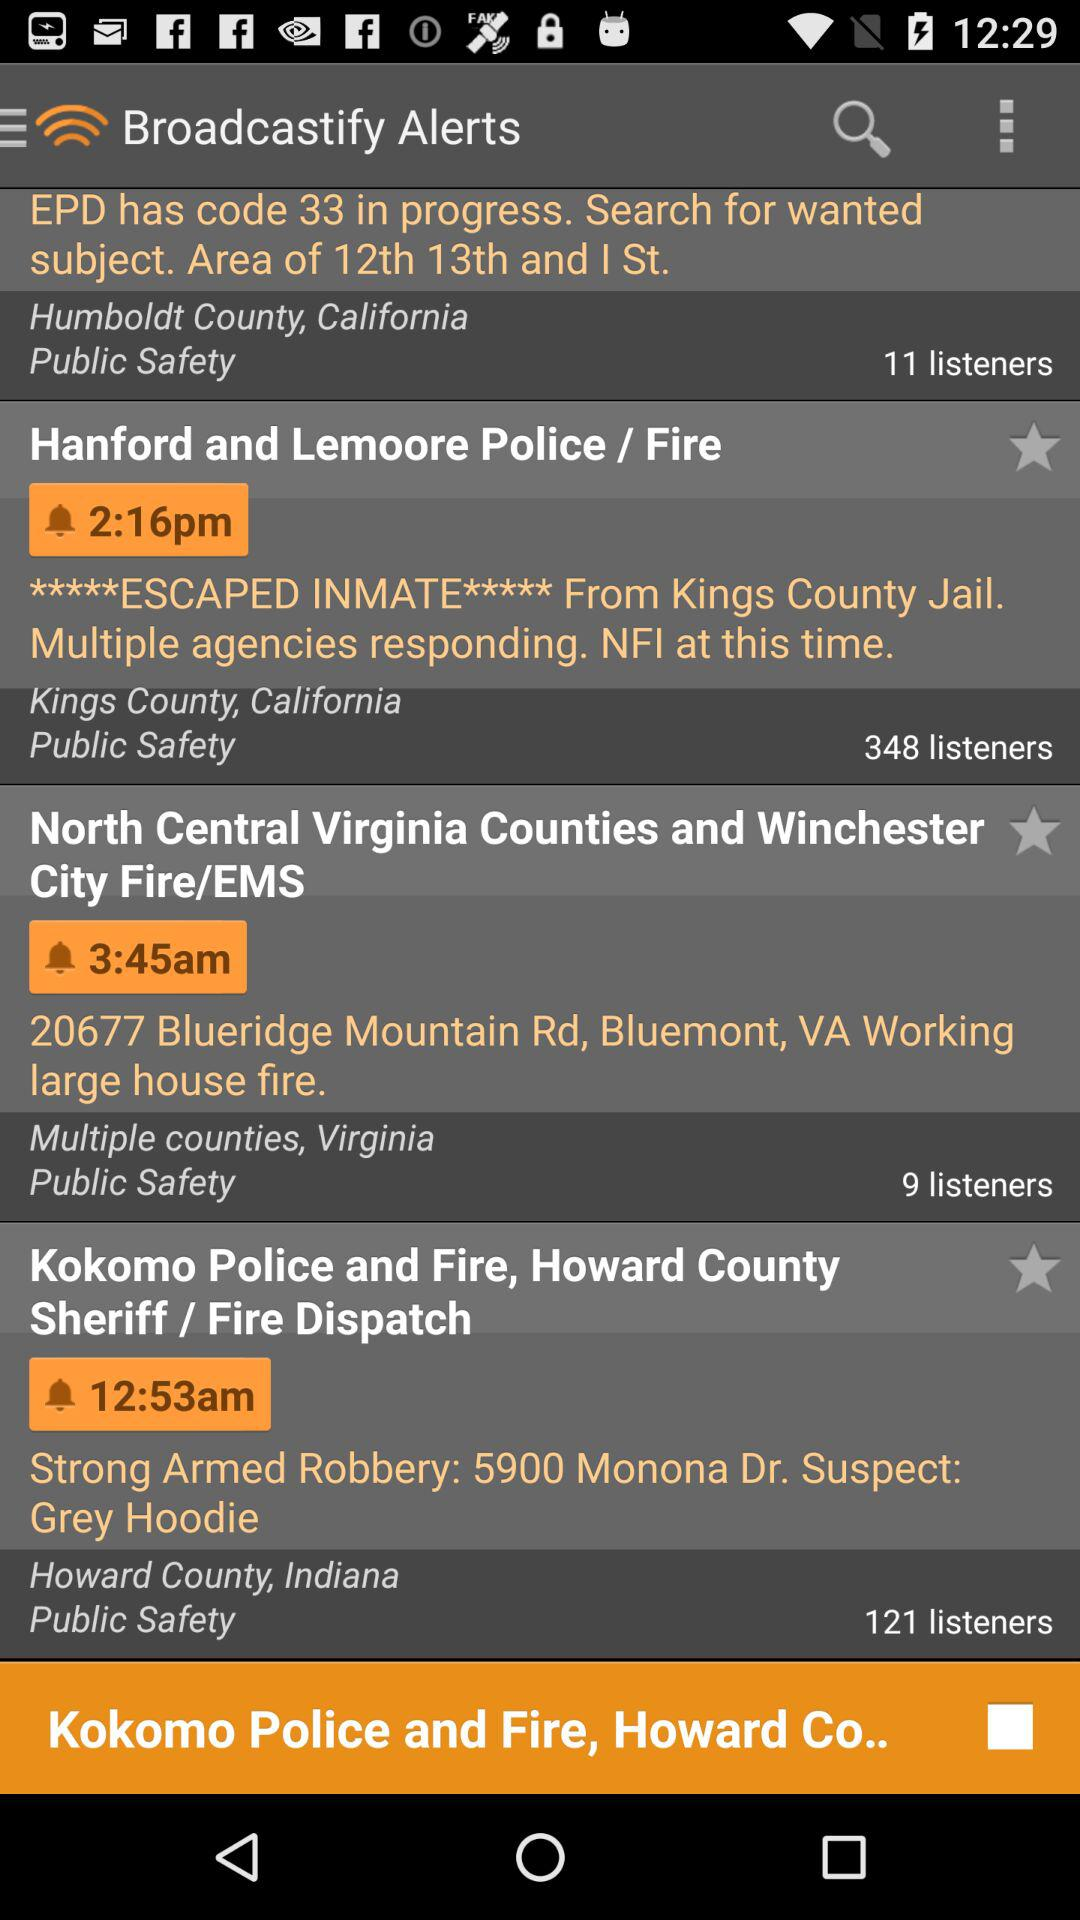What is the count of "Strong Armed Robbery: 5900 Monona Dr. Suspect: Grey Hoodie" listeners? The count is 121 listeners. 